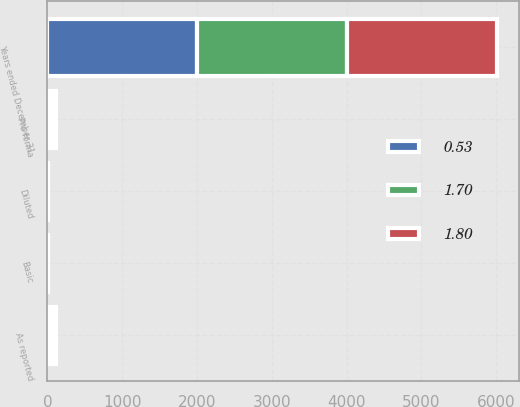Convert chart to OTSL. <chart><loc_0><loc_0><loc_500><loc_500><stacked_bar_chart><ecel><fcel>Years ended December 31<fcel>As reported<fcel>Pro forma<fcel>Basic<fcel>Diluted<nl><fcel>1.7<fcel>2003<fcel>52.2<fcel>50.4<fcel>1.8<fcel>1.76<nl><fcel>0.53<fcel>2002<fcel>51.3<fcel>49.7<fcel>1.9<fcel>1.86<nl><fcel>1.8<fcel>2001<fcel>14.5<fcel>12.7<fcel>0.61<fcel>0.61<nl></chart> 